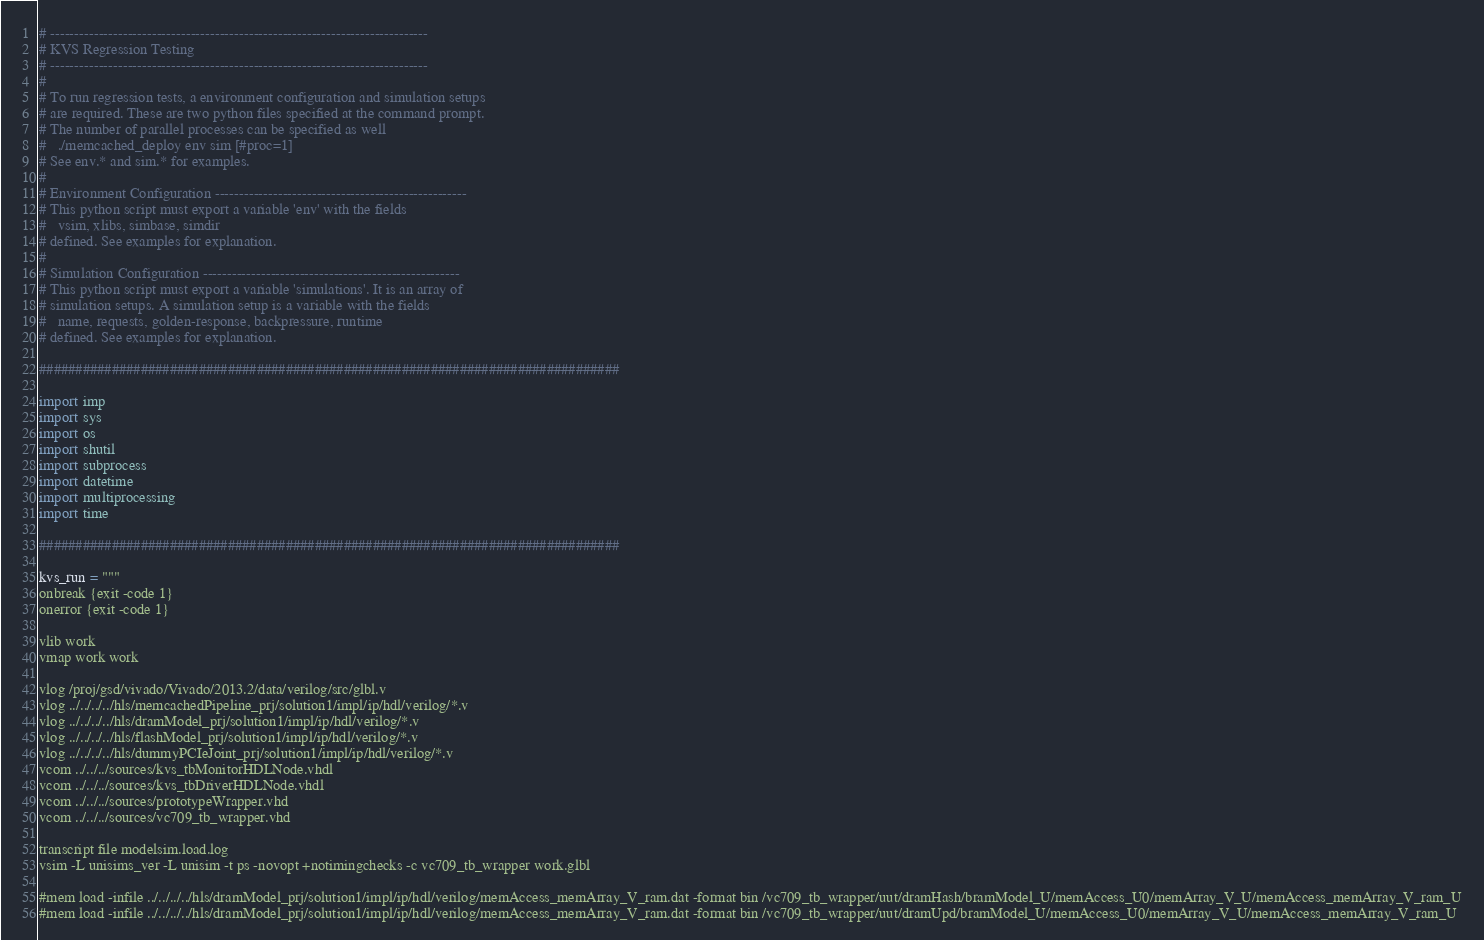<code> <loc_0><loc_0><loc_500><loc_500><_Python_>
# ------------------------------------------------------------------------------
# KVS Regression Testing
# ------------------------------------------------------------------------------
#
# To run regression tests, a environment configuration and simulation setups
# are required. These are two python files specified at the command prompt.
# The number of parallel processes can be specified as well
#   ./memcached_deploy env sim [#proc=1]
# See env.* and sim.* for examples.
#
# Environment Configuration ----------------------------------------------------
# This python script must export a variable 'env' with the fields
#   vsim, xlibs, simbase, simdir
# defined. See examples for explanation.
#
# Simulation Configuration -----------------------------------------------------
# This python script must export a variable 'simulations'. It is an array of
# simulation setups. A simulation setup is a variable with the fields
#   name, requests, golden-response, backpressure, runtime
# defined. See examples for explanation.

################################################################################

import imp
import sys
import os
import shutil
import subprocess
import datetime
import multiprocessing
import time

################################################################################

kvs_run = """
onbreak {exit -code 1}
onerror {exit -code 1}

vlib work
vmap work work

vlog /proj/gsd/vivado/Vivado/2013.2/data/verilog/src/glbl.v
vlog ../../../../hls/memcachedPipeline_prj/solution1/impl/ip/hdl/verilog/*.v
vlog ../../../../hls/dramModel_prj/solution1/impl/ip/hdl/verilog/*.v
vlog ../../../../hls/flashModel_prj/solution1/impl/ip/hdl/verilog/*.v
vlog ../../../../hls/dummyPCIeJoint_prj/solution1/impl/ip/hdl/verilog/*.v
vcom ../../../sources/kvs_tbMonitorHDLNode.vhdl
vcom ../../../sources/kvs_tbDriverHDLNode.vhdl
vcom ../../../sources/prototypeWrapper.vhd
vcom ../../../sources/vc709_tb_wrapper.vhd

transcript file modelsim.load.log
vsim -L unisims_ver -L unisim -t ps -novopt +notimingchecks -c vc709_tb_wrapper work.glbl

#mem load -infile ../../../../hls/dramModel_prj/solution1/impl/ip/hdl/verilog/memAccess_memArray_V_ram.dat -format bin /vc709_tb_wrapper/uut/dramHash/bramModel_U/memAccess_U0/memArray_V_U/memAccess_memArray_V_ram_U
#mem load -infile ../../../../hls/dramModel_prj/solution1/impl/ip/hdl/verilog/memAccess_memArray_V_ram.dat -format bin /vc709_tb_wrapper/uut/dramUpd/bramModel_U/memAccess_U0/memArray_V_U/memAccess_memArray_V_ram_U </code> 